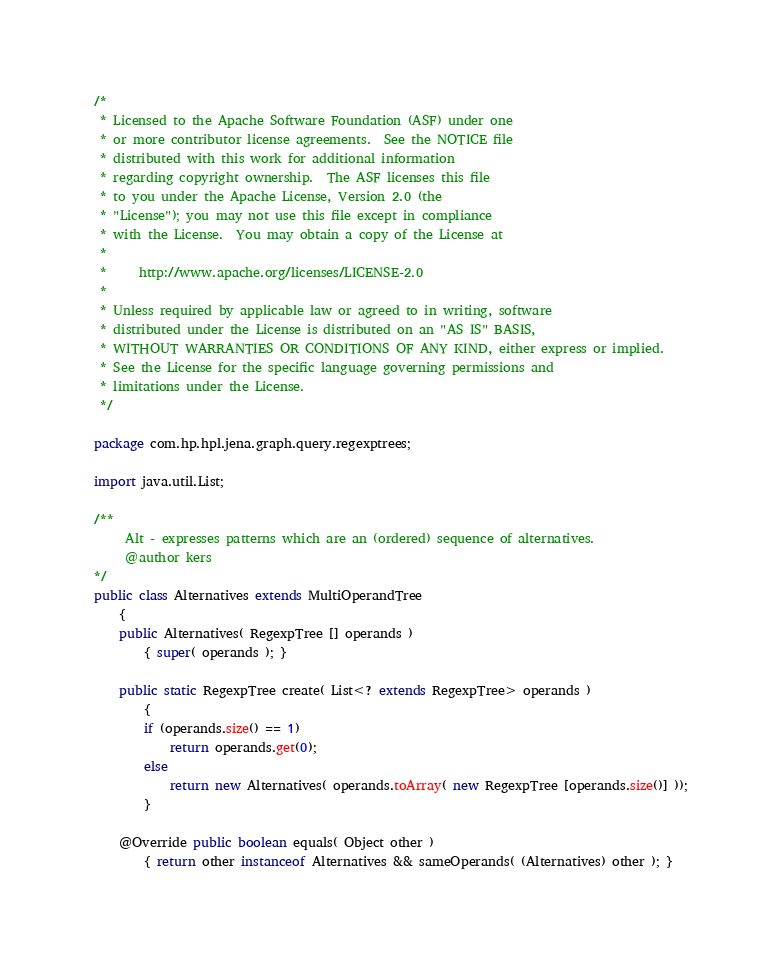<code> <loc_0><loc_0><loc_500><loc_500><_Java_>/*
 * Licensed to the Apache Software Foundation (ASF) under one
 * or more contributor license agreements.  See the NOTICE file
 * distributed with this work for additional information
 * regarding copyright ownership.  The ASF licenses this file
 * to you under the Apache License, Version 2.0 (the
 * "License"); you may not use this file except in compliance
 * with the License.  You may obtain a copy of the License at
 *
 *     http://www.apache.org/licenses/LICENSE-2.0
 *
 * Unless required by applicable law or agreed to in writing, software
 * distributed under the License is distributed on an "AS IS" BASIS,
 * WITHOUT WARRANTIES OR CONDITIONS OF ANY KIND, either express or implied.
 * See the License for the specific language governing permissions and
 * limitations under the License.
 */

package com.hp.hpl.jena.graph.query.regexptrees;

import java.util.List;

/**
     Alt - expresses patterns which are an (ordered) sequence of alternatives.
     @author kers
*/
public class Alternatives extends MultiOperandTree
    {
    public Alternatives( RegexpTree [] operands )
        { super( operands ); }
    
    public static RegexpTree create( List<? extends RegexpTree> operands )
        {
        if (operands.size() == 1) 
            return operands.get(0);
        else
            return new Alternatives( operands.toArray( new RegexpTree [operands.size()] ));
        }
    
    @Override public boolean equals( Object other )
        { return other instanceof Alternatives && sameOperands( (Alternatives) other ); }
</code> 